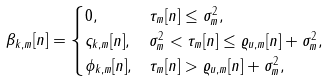Convert formula to latex. <formula><loc_0><loc_0><loc_500><loc_500>\beta _ { k , m } [ n ] & = \begin{cases} 0 , & \tau _ { m } [ n ] \leq \sigma _ { m } ^ { 2 } , \\ \varsigma _ { k , m } [ n ] , & \sigma _ { m } ^ { 2 } < \tau _ { m } [ n ] \leq \varrho _ { u , m } [ n ] + \sigma _ { m } ^ { 2 } , \\ \phi _ { k , m } [ n ] , & \tau _ { m } [ n ] > \varrho _ { u , m } [ n ] + \sigma _ { m } ^ { 2 } , \end{cases}</formula> 